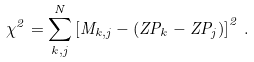<formula> <loc_0><loc_0><loc_500><loc_500>\chi ^ { 2 } = \sum _ { k , j } ^ { N } \left [ M _ { k , j } - ( Z P _ { k } - Z P _ { j } ) \right ] ^ { 2 } \, .</formula> 